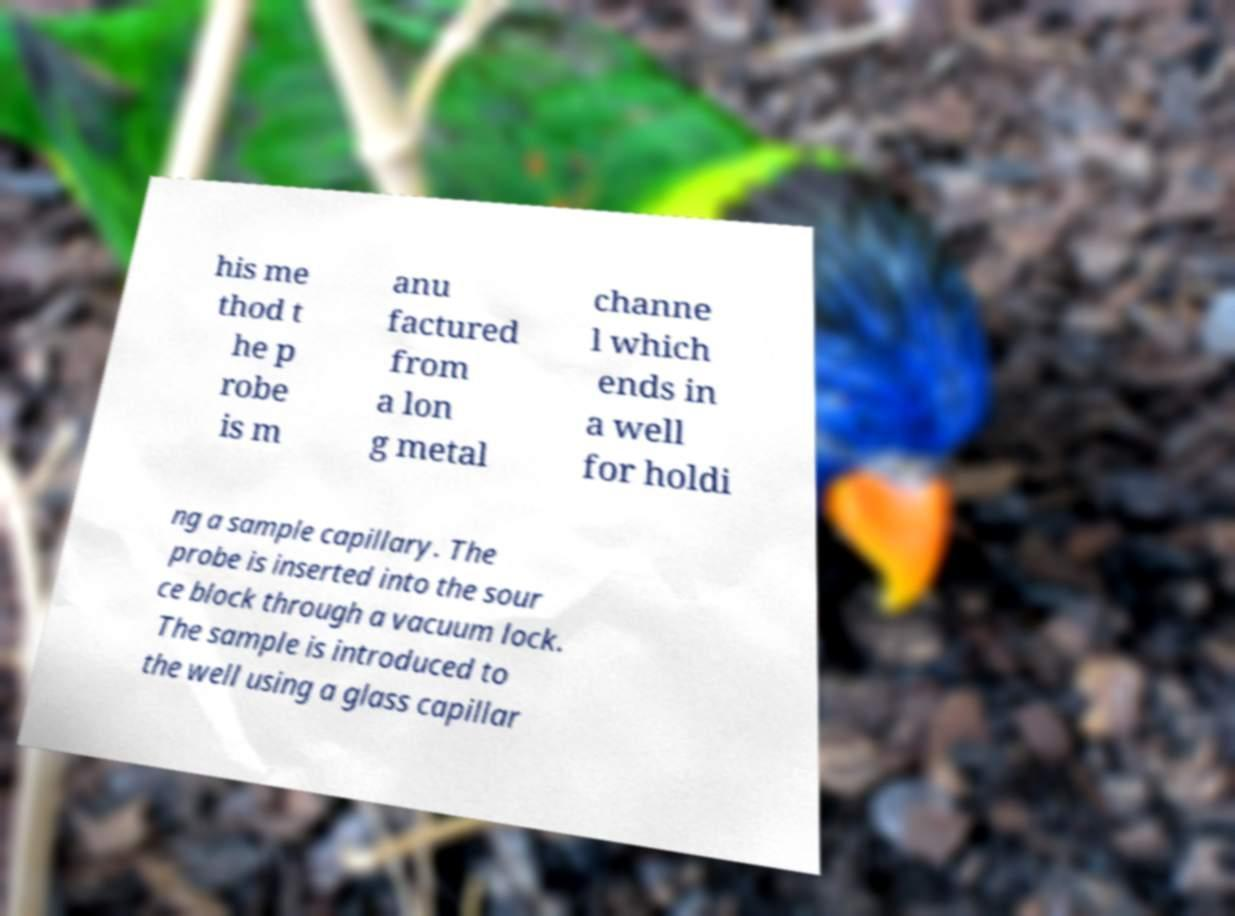Could you assist in decoding the text presented in this image and type it out clearly? his me thod t he p robe is m anu factured from a lon g metal channe l which ends in a well for holdi ng a sample capillary. The probe is inserted into the sour ce block through a vacuum lock. The sample is introduced to the well using a glass capillar 